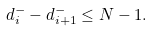Convert formula to latex. <formula><loc_0><loc_0><loc_500><loc_500>d _ { i } ^ { - } - d _ { i + 1 } ^ { - } \leq N - 1 .</formula> 